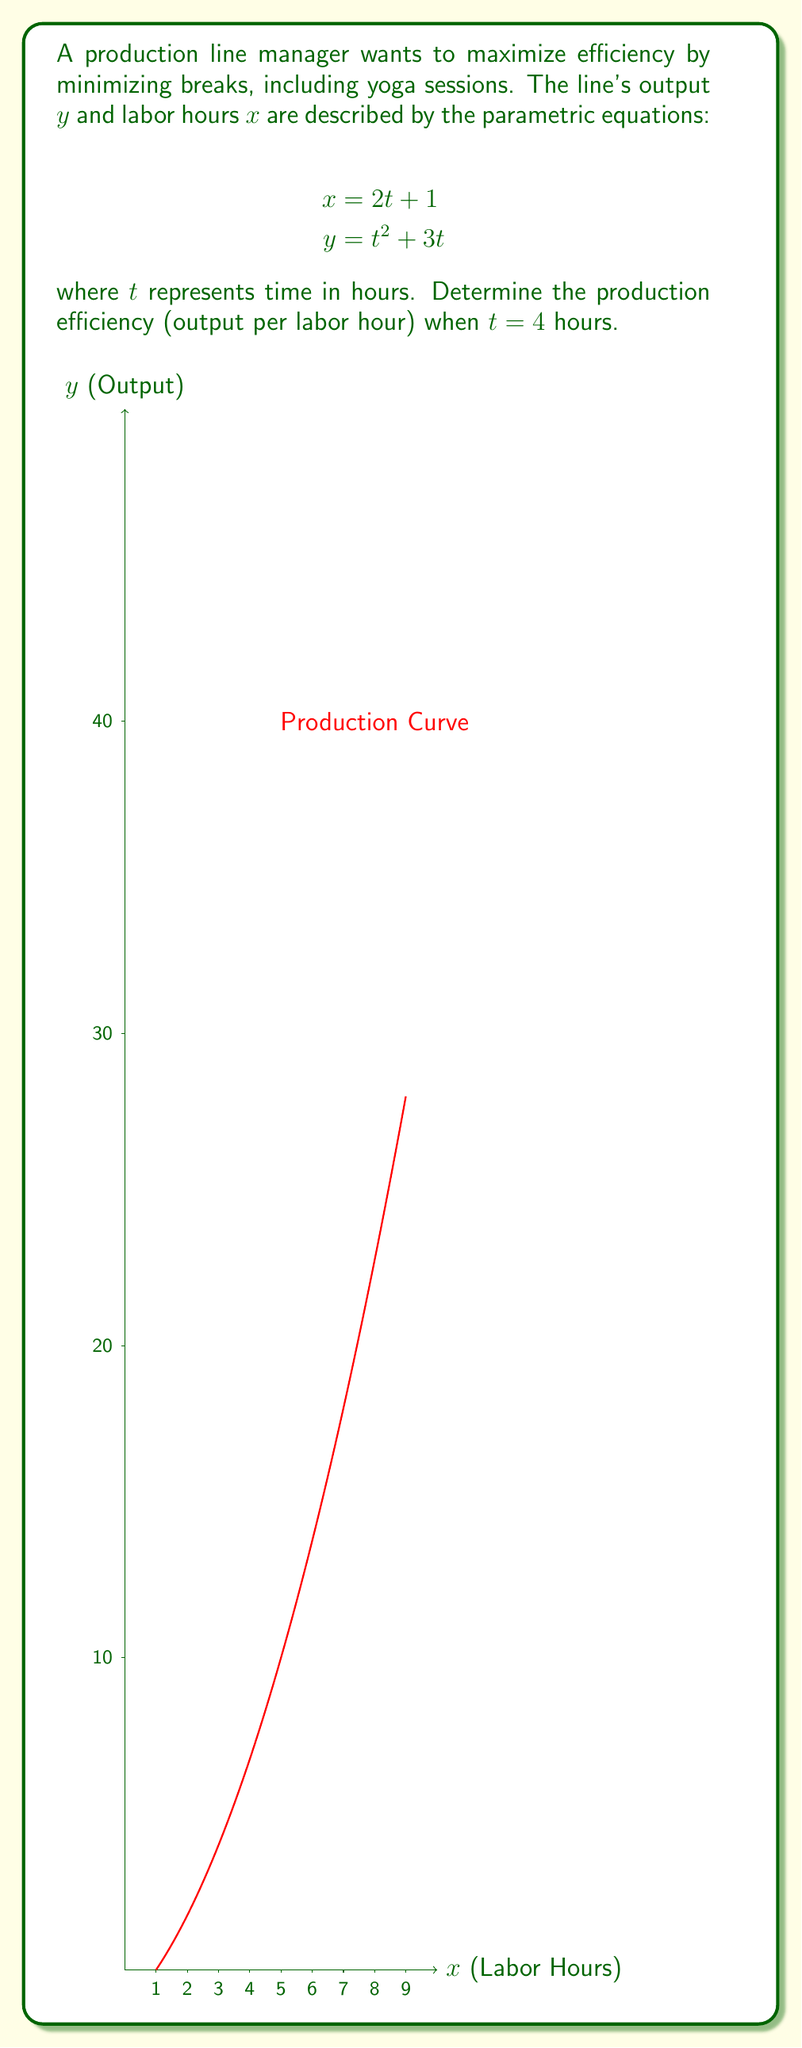Give your solution to this math problem. To find the production efficiency, we need to calculate the output per labor hour at $t = 4$. Let's follow these steps:

1) First, calculate the labor hours $x$ when $t = 4$:
   $$x = 2t + 1 = 2(4) + 1 = 9$$ labor hours

2) Next, calculate the output $y$ when $t = 4$:
   $$y = t^2 + 3t = 4^2 + 3(4) = 16 + 12 = 28$$ units

3) The production efficiency is the ratio of output to labor hours:
   $$\text{Efficiency} = \frac{\text{Output}}{\text{Labor Hours}} = \frac{y}{x} = \frac{28}{9}$$

4) Simplify the fraction:
   $$\frac{28}{9} = 3\frac{1}{9}$$ units per labor hour

This means that after 4 hours, the production line is producing 3.111... units per labor hour.
Answer: $3\frac{1}{9}$ units per labor hour 